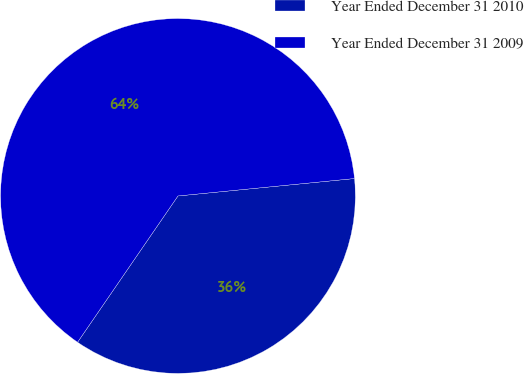Convert chart. <chart><loc_0><loc_0><loc_500><loc_500><pie_chart><fcel>Year Ended December 31 2010<fcel>Year Ended December 31 2009<nl><fcel>36.14%<fcel>63.86%<nl></chart> 